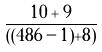<formula> <loc_0><loc_0><loc_500><loc_500>\frac { 1 0 + 9 } { ( ( 4 8 6 - 1 ) + 8 ) }</formula> 